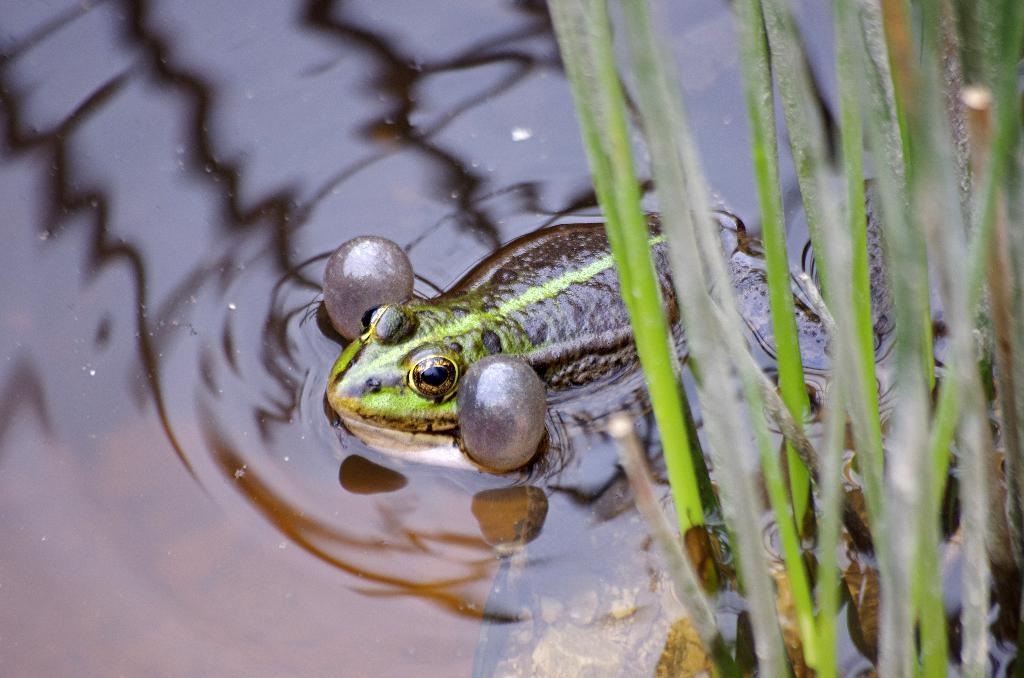What animal can be seen in the water in the image? There is a frog in the water in the image. What type of vegetation is on the right side of the image? There is grass on the right side of the image. What type of crown is the frog wearing in the image? There is no crown present in the image; the frog is not wearing any accessories. 